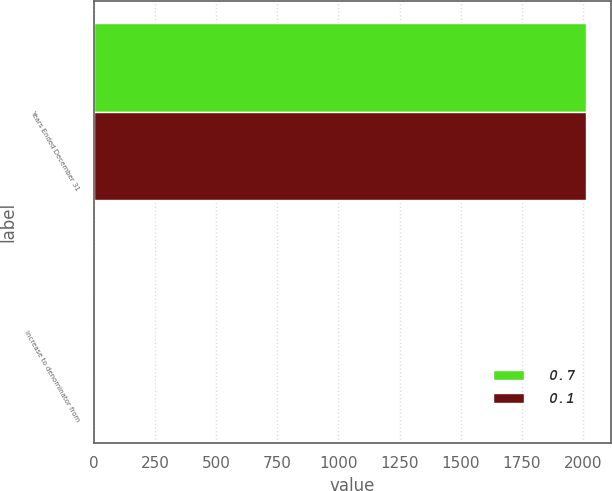Convert chart to OTSL. <chart><loc_0><loc_0><loc_500><loc_500><stacked_bar_chart><ecel><fcel>Years Ended December 31<fcel>Increase to denominator from<nl><fcel>0.7<fcel>2012<fcel>0.1<nl><fcel>0.1<fcel>2011<fcel>0.7<nl></chart> 